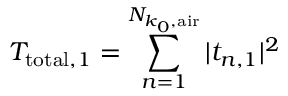<formula> <loc_0><loc_0><loc_500><loc_500>T _ { t o t a l , 1 } = \sum _ { n = 1 } ^ { N _ { k _ { 0 } , a i r } } | t _ { n , 1 } | ^ { 2 }</formula> 